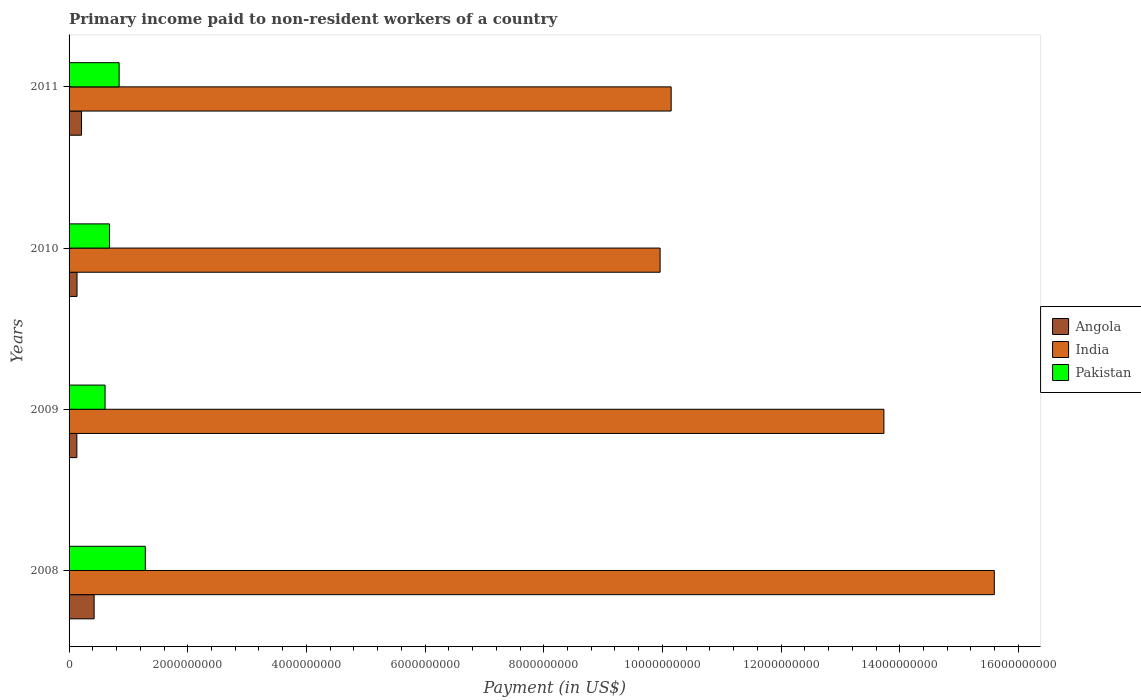How many groups of bars are there?
Keep it short and to the point. 4. Are the number of bars per tick equal to the number of legend labels?
Your response must be concise. Yes. Are the number of bars on each tick of the Y-axis equal?
Your response must be concise. Yes. What is the label of the 2nd group of bars from the top?
Offer a very short reply. 2010. What is the amount paid to workers in Angola in 2010?
Provide a succinct answer. 1.34e+08. Across all years, what is the maximum amount paid to workers in Angola?
Make the answer very short. 4.22e+08. Across all years, what is the minimum amount paid to workers in Angola?
Ensure brevity in your answer.  1.31e+08. What is the total amount paid to workers in Pakistan in the graph?
Your answer should be very brief. 3.42e+09. What is the difference between the amount paid to workers in Pakistan in 2009 and that in 2011?
Your answer should be very brief. -2.37e+08. What is the difference between the amount paid to workers in Pakistan in 2009 and the amount paid to workers in India in 2008?
Offer a terse response. -1.50e+1. What is the average amount paid to workers in India per year?
Give a very brief answer. 1.24e+1. In the year 2010, what is the difference between the amount paid to workers in Angola and amount paid to workers in India?
Offer a very short reply. -9.83e+09. In how many years, is the amount paid to workers in Angola greater than 400000000 US$?
Keep it short and to the point. 1. What is the ratio of the amount paid to workers in India in 2008 to that in 2011?
Ensure brevity in your answer.  1.54. Is the amount paid to workers in Angola in 2010 less than that in 2011?
Offer a very short reply. Yes. Is the difference between the amount paid to workers in Angola in 2008 and 2011 greater than the difference between the amount paid to workers in India in 2008 and 2011?
Ensure brevity in your answer.  No. What is the difference between the highest and the second highest amount paid to workers in India?
Offer a terse response. 1.86e+09. What is the difference between the highest and the lowest amount paid to workers in Angola?
Offer a terse response. 2.91e+08. What does the 3rd bar from the top in 2008 represents?
Offer a very short reply. Angola. What does the 1st bar from the bottom in 2010 represents?
Provide a short and direct response. Angola. Is it the case that in every year, the sum of the amount paid to workers in Pakistan and amount paid to workers in Angola is greater than the amount paid to workers in India?
Make the answer very short. No. Are all the bars in the graph horizontal?
Your response must be concise. Yes. How many years are there in the graph?
Provide a succinct answer. 4. Does the graph contain any zero values?
Your response must be concise. No. How many legend labels are there?
Provide a short and direct response. 3. How are the legend labels stacked?
Give a very brief answer. Vertical. What is the title of the graph?
Your response must be concise. Primary income paid to non-resident workers of a country. Does "East Asia (developing only)" appear as one of the legend labels in the graph?
Your answer should be very brief. No. What is the label or title of the X-axis?
Make the answer very short. Payment (in US$). What is the Payment (in US$) of Angola in 2008?
Your answer should be compact. 4.22e+08. What is the Payment (in US$) in India in 2008?
Keep it short and to the point. 1.56e+1. What is the Payment (in US$) in Pakistan in 2008?
Offer a terse response. 1.28e+09. What is the Payment (in US$) of Angola in 2009?
Keep it short and to the point. 1.31e+08. What is the Payment (in US$) in India in 2009?
Keep it short and to the point. 1.37e+1. What is the Payment (in US$) in Pakistan in 2009?
Give a very brief answer. 6.07e+08. What is the Payment (in US$) in Angola in 2010?
Provide a short and direct response. 1.34e+08. What is the Payment (in US$) in India in 2010?
Make the answer very short. 9.96e+09. What is the Payment (in US$) of Pakistan in 2010?
Provide a succinct answer. 6.81e+08. What is the Payment (in US$) of Angola in 2011?
Provide a short and direct response. 2.10e+08. What is the Payment (in US$) in India in 2011?
Keep it short and to the point. 1.01e+1. What is the Payment (in US$) in Pakistan in 2011?
Your answer should be compact. 8.44e+08. Across all years, what is the maximum Payment (in US$) in Angola?
Offer a terse response. 4.22e+08. Across all years, what is the maximum Payment (in US$) of India?
Ensure brevity in your answer.  1.56e+1. Across all years, what is the maximum Payment (in US$) in Pakistan?
Provide a succinct answer. 1.28e+09. Across all years, what is the minimum Payment (in US$) in Angola?
Offer a very short reply. 1.31e+08. Across all years, what is the minimum Payment (in US$) of India?
Provide a succinct answer. 9.96e+09. Across all years, what is the minimum Payment (in US$) of Pakistan?
Offer a terse response. 6.07e+08. What is the total Payment (in US$) in Angola in the graph?
Make the answer very short. 8.97e+08. What is the total Payment (in US$) of India in the graph?
Ensure brevity in your answer.  4.94e+1. What is the total Payment (in US$) in Pakistan in the graph?
Your answer should be compact. 3.42e+09. What is the difference between the Payment (in US$) of Angola in 2008 and that in 2009?
Provide a short and direct response. 2.91e+08. What is the difference between the Payment (in US$) of India in 2008 and that in 2009?
Offer a very short reply. 1.86e+09. What is the difference between the Payment (in US$) in Pakistan in 2008 and that in 2009?
Give a very brief answer. 6.78e+08. What is the difference between the Payment (in US$) of Angola in 2008 and that in 2010?
Your answer should be very brief. 2.88e+08. What is the difference between the Payment (in US$) in India in 2008 and that in 2010?
Provide a short and direct response. 5.63e+09. What is the difference between the Payment (in US$) in Pakistan in 2008 and that in 2010?
Offer a terse response. 6.04e+08. What is the difference between the Payment (in US$) of Angola in 2008 and that in 2011?
Ensure brevity in your answer.  2.12e+08. What is the difference between the Payment (in US$) of India in 2008 and that in 2011?
Give a very brief answer. 5.45e+09. What is the difference between the Payment (in US$) in Pakistan in 2008 and that in 2011?
Your response must be concise. 4.41e+08. What is the difference between the Payment (in US$) of Angola in 2009 and that in 2010?
Ensure brevity in your answer.  -2.70e+06. What is the difference between the Payment (in US$) in India in 2009 and that in 2010?
Give a very brief answer. 3.77e+09. What is the difference between the Payment (in US$) in Pakistan in 2009 and that in 2010?
Keep it short and to the point. -7.40e+07. What is the difference between the Payment (in US$) of Angola in 2009 and that in 2011?
Ensure brevity in your answer.  -7.85e+07. What is the difference between the Payment (in US$) in India in 2009 and that in 2011?
Provide a short and direct response. 3.59e+09. What is the difference between the Payment (in US$) in Pakistan in 2009 and that in 2011?
Give a very brief answer. -2.37e+08. What is the difference between the Payment (in US$) in Angola in 2010 and that in 2011?
Ensure brevity in your answer.  -7.58e+07. What is the difference between the Payment (in US$) in India in 2010 and that in 2011?
Give a very brief answer. -1.86e+08. What is the difference between the Payment (in US$) of Pakistan in 2010 and that in 2011?
Ensure brevity in your answer.  -1.63e+08. What is the difference between the Payment (in US$) of Angola in 2008 and the Payment (in US$) of India in 2009?
Your response must be concise. -1.33e+1. What is the difference between the Payment (in US$) of Angola in 2008 and the Payment (in US$) of Pakistan in 2009?
Keep it short and to the point. -1.85e+08. What is the difference between the Payment (in US$) in India in 2008 and the Payment (in US$) in Pakistan in 2009?
Keep it short and to the point. 1.50e+1. What is the difference between the Payment (in US$) of Angola in 2008 and the Payment (in US$) of India in 2010?
Offer a terse response. -9.54e+09. What is the difference between the Payment (in US$) in Angola in 2008 and the Payment (in US$) in Pakistan in 2010?
Your answer should be compact. -2.59e+08. What is the difference between the Payment (in US$) of India in 2008 and the Payment (in US$) of Pakistan in 2010?
Your answer should be very brief. 1.49e+1. What is the difference between the Payment (in US$) of Angola in 2008 and the Payment (in US$) of India in 2011?
Make the answer very short. -9.72e+09. What is the difference between the Payment (in US$) of Angola in 2008 and the Payment (in US$) of Pakistan in 2011?
Your answer should be compact. -4.22e+08. What is the difference between the Payment (in US$) in India in 2008 and the Payment (in US$) in Pakistan in 2011?
Give a very brief answer. 1.47e+1. What is the difference between the Payment (in US$) of Angola in 2009 and the Payment (in US$) of India in 2010?
Your response must be concise. -9.83e+09. What is the difference between the Payment (in US$) of Angola in 2009 and the Payment (in US$) of Pakistan in 2010?
Provide a succinct answer. -5.50e+08. What is the difference between the Payment (in US$) in India in 2009 and the Payment (in US$) in Pakistan in 2010?
Keep it short and to the point. 1.31e+1. What is the difference between the Payment (in US$) of Angola in 2009 and the Payment (in US$) of India in 2011?
Offer a very short reply. -1.00e+1. What is the difference between the Payment (in US$) in Angola in 2009 and the Payment (in US$) in Pakistan in 2011?
Your response must be concise. -7.13e+08. What is the difference between the Payment (in US$) in India in 2009 and the Payment (in US$) in Pakistan in 2011?
Give a very brief answer. 1.29e+1. What is the difference between the Payment (in US$) in Angola in 2010 and the Payment (in US$) in India in 2011?
Provide a short and direct response. -1.00e+1. What is the difference between the Payment (in US$) of Angola in 2010 and the Payment (in US$) of Pakistan in 2011?
Make the answer very short. -7.10e+08. What is the difference between the Payment (in US$) of India in 2010 and the Payment (in US$) of Pakistan in 2011?
Provide a succinct answer. 9.12e+09. What is the average Payment (in US$) of Angola per year?
Ensure brevity in your answer.  2.24e+08. What is the average Payment (in US$) of India per year?
Make the answer very short. 1.24e+1. What is the average Payment (in US$) of Pakistan per year?
Your answer should be compact. 8.54e+08. In the year 2008, what is the difference between the Payment (in US$) in Angola and Payment (in US$) in India?
Offer a very short reply. -1.52e+1. In the year 2008, what is the difference between the Payment (in US$) of Angola and Payment (in US$) of Pakistan?
Your answer should be compact. -8.63e+08. In the year 2008, what is the difference between the Payment (in US$) in India and Payment (in US$) in Pakistan?
Provide a short and direct response. 1.43e+1. In the year 2009, what is the difference between the Payment (in US$) in Angola and Payment (in US$) in India?
Offer a terse response. -1.36e+1. In the year 2009, what is the difference between the Payment (in US$) in Angola and Payment (in US$) in Pakistan?
Your answer should be very brief. -4.76e+08. In the year 2009, what is the difference between the Payment (in US$) of India and Payment (in US$) of Pakistan?
Your response must be concise. 1.31e+1. In the year 2010, what is the difference between the Payment (in US$) in Angola and Payment (in US$) in India?
Give a very brief answer. -9.83e+09. In the year 2010, what is the difference between the Payment (in US$) of Angola and Payment (in US$) of Pakistan?
Keep it short and to the point. -5.47e+08. In the year 2010, what is the difference between the Payment (in US$) of India and Payment (in US$) of Pakistan?
Provide a short and direct response. 9.28e+09. In the year 2011, what is the difference between the Payment (in US$) of Angola and Payment (in US$) of India?
Ensure brevity in your answer.  -9.94e+09. In the year 2011, what is the difference between the Payment (in US$) of Angola and Payment (in US$) of Pakistan?
Make the answer very short. -6.34e+08. In the year 2011, what is the difference between the Payment (in US$) of India and Payment (in US$) of Pakistan?
Offer a terse response. 9.30e+09. What is the ratio of the Payment (in US$) of Angola in 2008 to that in 2009?
Your answer should be very brief. 3.22. What is the ratio of the Payment (in US$) of India in 2008 to that in 2009?
Provide a succinct answer. 1.14. What is the ratio of the Payment (in US$) in Pakistan in 2008 to that in 2009?
Ensure brevity in your answer.  2.12. What is the ratio of the Payment (in US$) in Angola in 2008 to that in 2010?
Provide a short and direct response. 3.15. What is the ratio of the Payment (in US$) of India in 2008 to that in 2010?
Provide a short and direct response. 1.57. What is the ratio of the Payment (in US$) in Pakistan in 2008 to that in 2010?
Your answer should be compact. 1.89. What is the ratio of the Payment (in US$) in Angola in 2008 to that in 2011?
Offer a terse response. 2.01. What is the ratio of the Payment (in US$) in India in 2008 to that in 2011?
Give a very brief answer. 1.54. What is the ratio of the Payment (in US$) in Pakistan in 2008 to that in 2011?
Make the answer very short. 1.52. What is the ratio of the Payment (in US$) of Angola in 2009 to that in 2010?
Give a very brief answer. 0.98. What is the ratio of the Payment (in US$) of India in 2009 to that in 2010?
Your response must be concise. 1.38. What is the ratio of the Payment (in US$) of Pakistan in 2009 to that in 2010?
Provide a succinct answer. 0.89. What is the ratio of the Payment (in US$) in Angola in 2009 to that in 2011?
Your answer should be very brief. 0.63. What is the ratio of the Payment (in US$) in India in 2009 to that in 2011?
Keep it short and to the point. 1.35. What is the ratio of the Payment (in US$) in Pakistan in 2009 to that in 2011?
Provide a succinct answer. 0.72. What is the ratio of the Payment (in US$) in Angola in 2010 to that in 2011?
Offer a terse response. 0.64. What is the ratio of the Payment (in US$) in India in 2010 to that in 2011?
Give a very brief answer. 0.98. What is the ratio of the Payment (in US$) of Pakistan in 2010 to that in 2011?
Your answer should be very brief. 0.81. What is the difference between the highest and the second highest Payment (in US$) of Angola?
Keep it short and to the point. 2.12e+08. What is the difference between the highest and the second highest Payment (in US$) in India?
Provide a succinct answer. 1.86e+09. What is the difference between the highest and the second highest Payment (in US$) of Pakistan?
Your answer should be very brief. 4.41e+08. What is the difference between the highest and the lowest Payment (in US$) of Angola?
Your answer should be compact. 2.91e+08. What is the difference between the highest and the lowest Payment (in US$) in India?
Your response must be concise. 5.63e+09. What is the difference between the highest and the lowest Payment (in US$) of Pakistan?
Provide a short and direct response. 6.78e+08. 